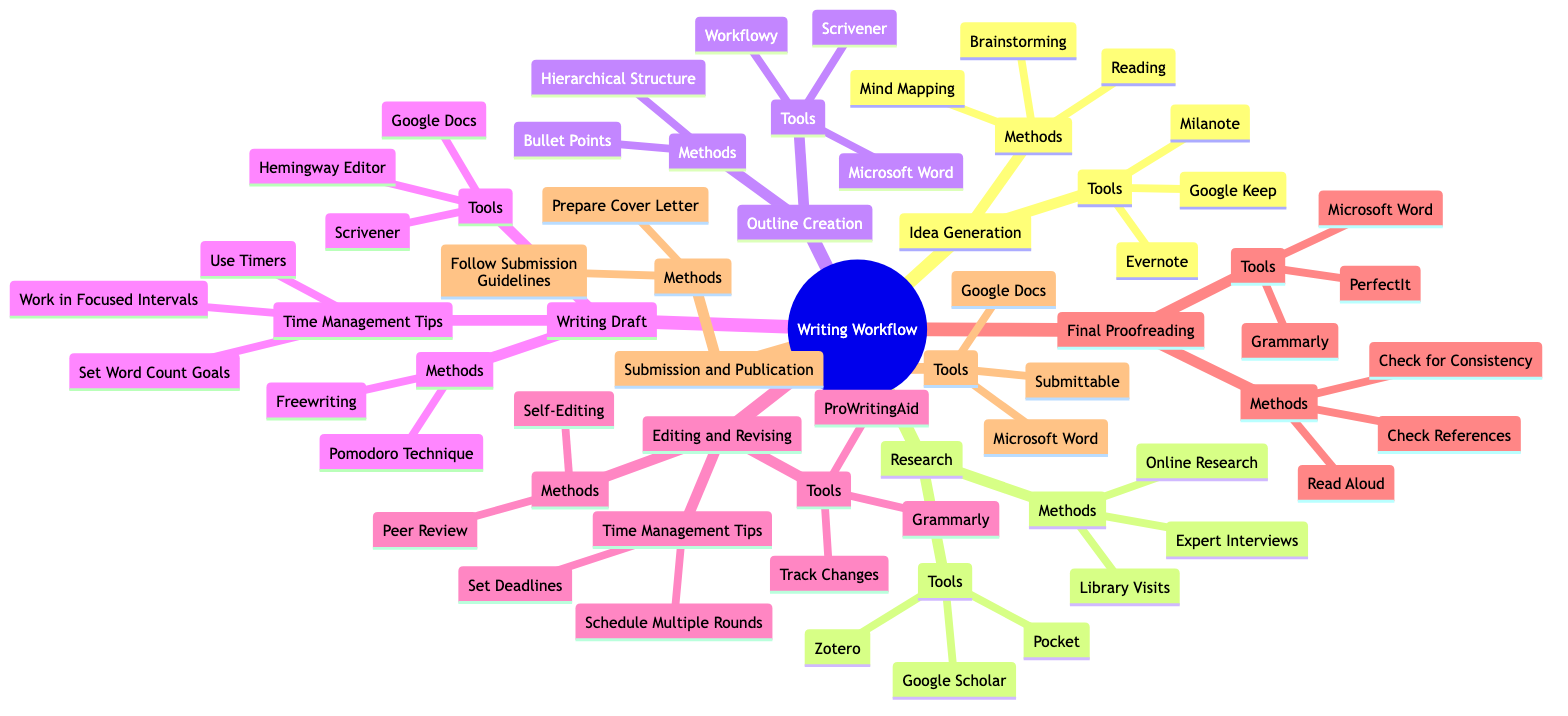What is the first stage in the writing workflow? The diagram clearly shows that the first stage is "Idea Generation." This is depicted at the top of the mind map as the first main node.
Answer: Idea Generation How many methods are listed for the Writing Draft stage? In the Writing Draft section, there are two methods mentioned: "Freewriting" and "Pomodoro Technique." Thus, counting the items directly from this node gives us two methods.
Answer: 2 What tool is associated with Outline Creation? In the Outline Creation section, the tools listed include "Scrivener," "Microsoft Word," and "Workflowy." Therefore, we can identify that "Scrivener" is one of the tools that are associated directly.
Answer: Scrivener Which stage includes the method 'Peer Review'? Looking at the stages, 'Peer Review' is found under the Editing and Revising section. By following the connections down from the main node, we see this method is specifically categorized there.
Answer: Editing and Revising What are the time management tips for the Writing Draft stage? The diagram lists three specific time management tips under the Writing Draft stage: "Set Word Count Goals," "Use Timers," and "Work in Focused Intervals." Thus, we can summarize these tips neatly from that node.
Answer: Set Word Count Goals, Use Timers, Work in Focused Intervals How many tools are mentioned for Final Proofreading? The Final Proofreading stage lists three tools: "Grammarly," "PerfectIt," and "Microsoft Word." Since we can see all three tools directly under this node, we count them for the answer.
Answer: 3 In the Submission and Publication stage, what is one required method? According to the Submission and Publication section, one of the methods is to "Follow Submission Guidelines." This is directly stated in the methods listed under this part of the mind map.
Answer: Follow Submission Guidelines What is the last main stage in the writing workflow? The last main stage in the writing workflow as presented in the mind map is "Submission and Publication." This can be found at the bottom of the diagram structure.
Answer: Submission and Publication 